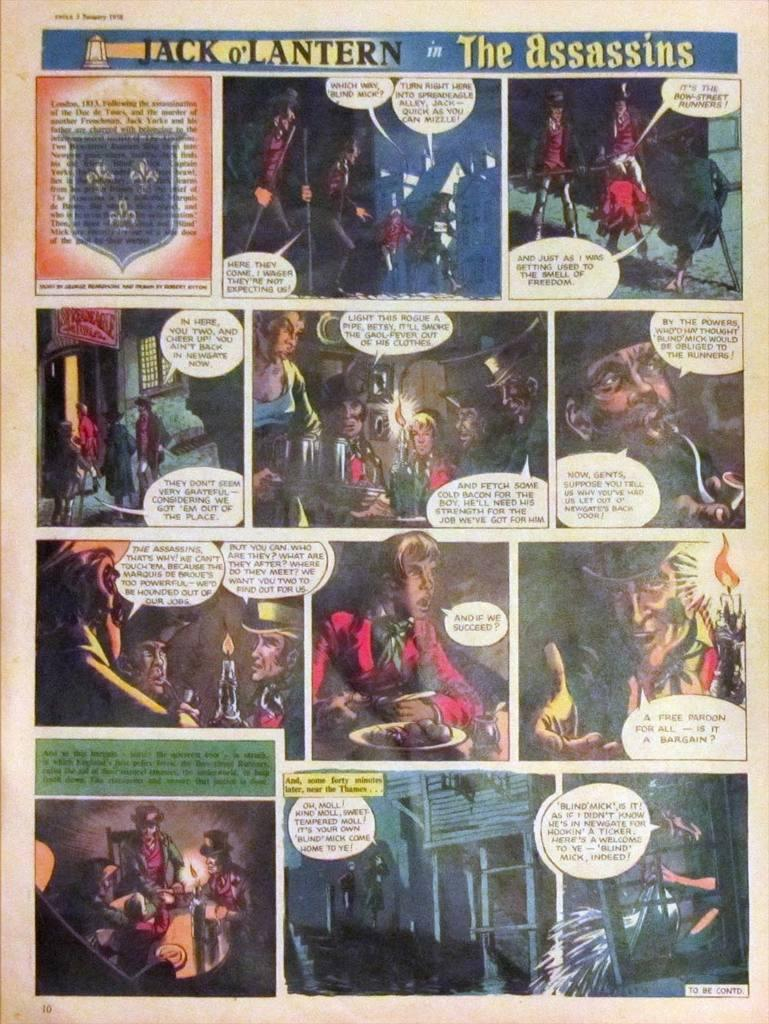What type of content is displayed in the image? There is a comic book page in the image. What can be found on the comic book page? There is text and cartoon images on the comic book page. How many mice are hiding behind the cartoon images on the comic book page? There are no mice present in the image; it only features text and cartoon images on a comic book page. 